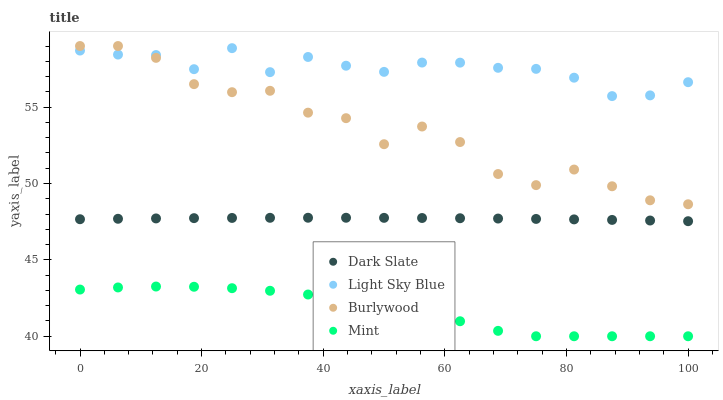Does Mint have the minimum area under the curve?
Answer yes or no. Yes. Does Light Sky Blue have the maximum area under the curve?
Answer yes or no. Yes. Does Dark Slate have the minimum area under the curve?
Answer yes or no. No. Does Dark Slate have the maximum area under the curve?
Answer yes or no. No. Is Dark Slate the smoothest?
Answer yes or no. Yes. Is Burlywood the roughest?
Answer yes or no. Yes. Is Light Sky Blue the smoothest?
Answer yes or no. No. Is Light Sky Blue the roughest?
Answer yes or no. No. Does Mint have the lowest value?
Answer yes or no. Yes. Does Dark Slate have the lowest value?
Answer yes or no. No. Does Burlywood have the highest value?
Answer yes or no. Yes. Does Dark Slate have the highest value?
Answer yes or no. No. Is Dark Slate less than Light Sky Blue?
Answer yes or no. Yes. Is Burlywood greater than Dark Slate?
Answer yes or no. Yes. Does Light Sky Blue intersect Burlywood?
Answer yes or no. Yes. Is Light Sky Blue less than Burlywood?
Answer yes or no. No. Is Light Sky Blue greater than Burlywood?
Answer yes or no. No. Does Dark Slate intersect Light Sky Blue?
Answer yes or no. No. 